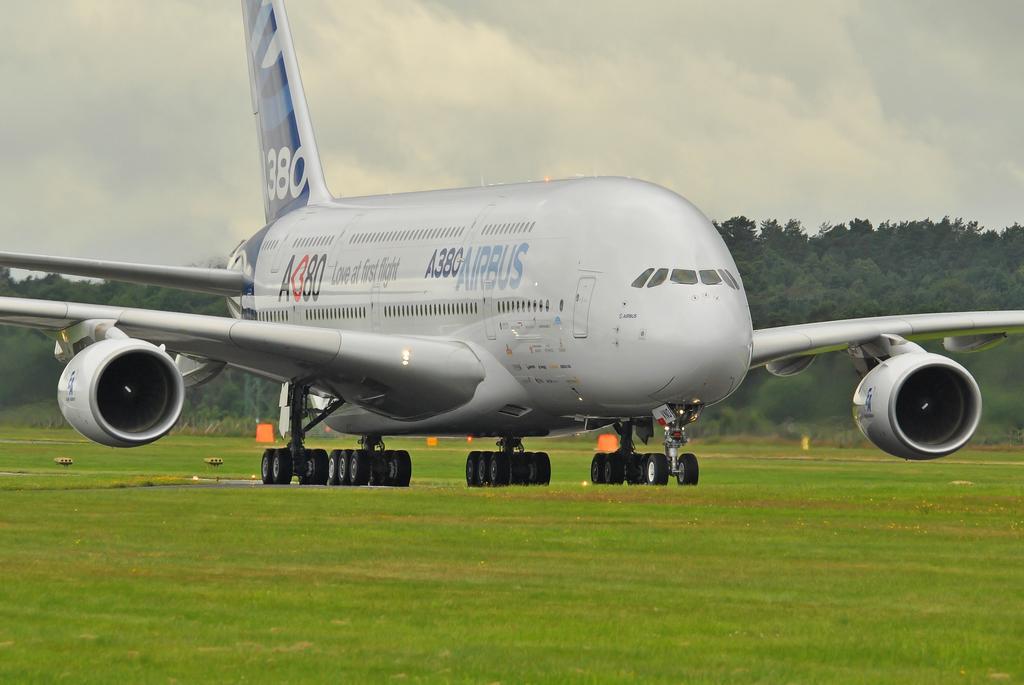Describe this image in one or two sentences. In this image I can see an aeroplane which is in white color and I can see wheels. Back I can see few trees and boards. The sky is in white color. 